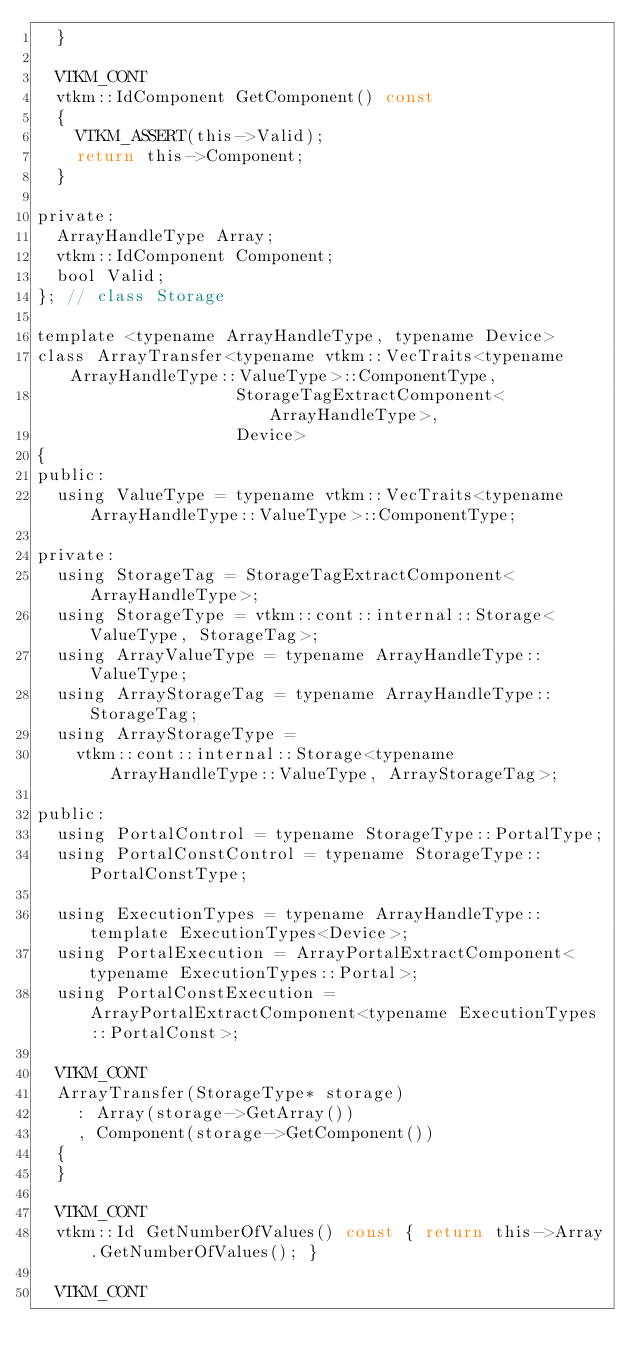<code> <loc_0><loc_0><loc_500><loc_500><_C_>  }

  VTKM_CONT
  vtkm::IdComponent GetComponent() const
  {
    VTKM_ASSERT(this->Valid);
    return this->Component;
  }

private:
  ArrayHandleType Array;
  vtkm::IdComponent Component;
  bool Valid;
}; // class Storage

template <typename ArrayHandleType, typename Device>
class ArrayTransfer<typename vtkm::VecTraits<typename ArrayHandleType::ValueType>::ComponentType,
                    StorageTagExtractComponent<ArrayHandleType>,
                    Device>
{
public:
  using ValueType = typename vtkm::VecTraits<typename ArrayHandleType::ValueType>::ComponentType;

private:
  using StorageTag = StorageTagExtractComponent<ArrayHandleType>;
  using StorageType = vtkm::cont::internal::Storage<ValueType, StorageTag>;
  using ArrayValueType = typename ArrayHandleType::ValueType;
  using ArrayStorageTag = typename ArrayHandleType::StorageTag;
  using ArrayStorageType =
    vtkm::cont::internal::Storage<typename ArrayHandleType::ValueType, ArrayStorageTag>;

public:
  using PortalControl = typename StorageType::PortalType;
  using PortalConstControl = typename StorageType::PortalConstType;

  using ExecutionTypes = typename ArrayHandleType::template ExecutionTypes<Device>;
  using PortalExecution = ArrayPortalExtractComponent<typename ExecutionTypes::Portal>;
  using PortalConstExecution = ArrayPortalExtractComponent<typename ExecutionTypes::PortalConst>;

  VTKM_CONT
  ArrayTransfer(StorageType* storage)
    : Array(storage->GetArray())
    , Component(storage->GetComponent())
  {
  }

  VTKM_CONT
  vtkm::Id GetNumberOfValues() const { return this->Array.GetNumberOfValues(); }

  VTKM_CONT</code> 